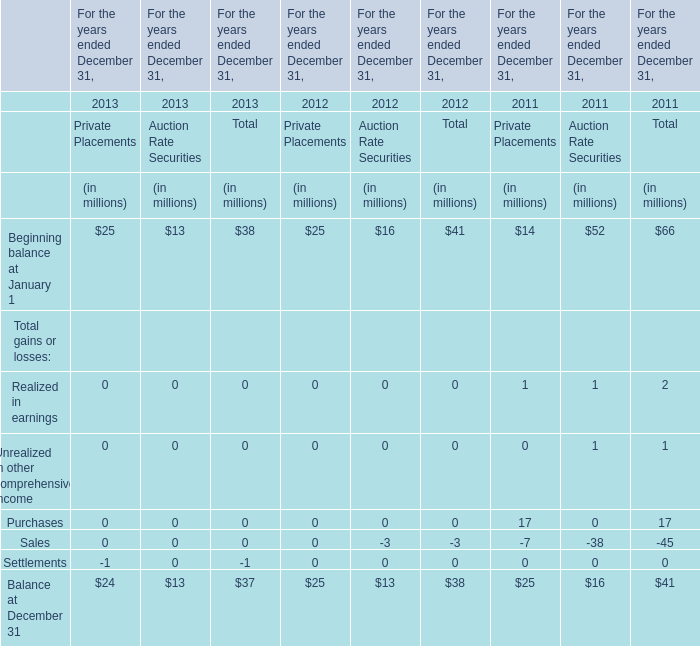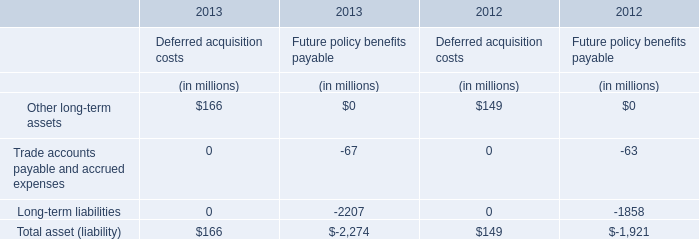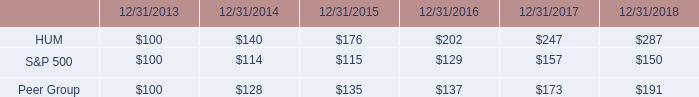In which year is Beginning balance at January 1 of Private Placements smaller than Beginning balance at January 1 of Auction Rate Securities? 
Answer: 2011. 